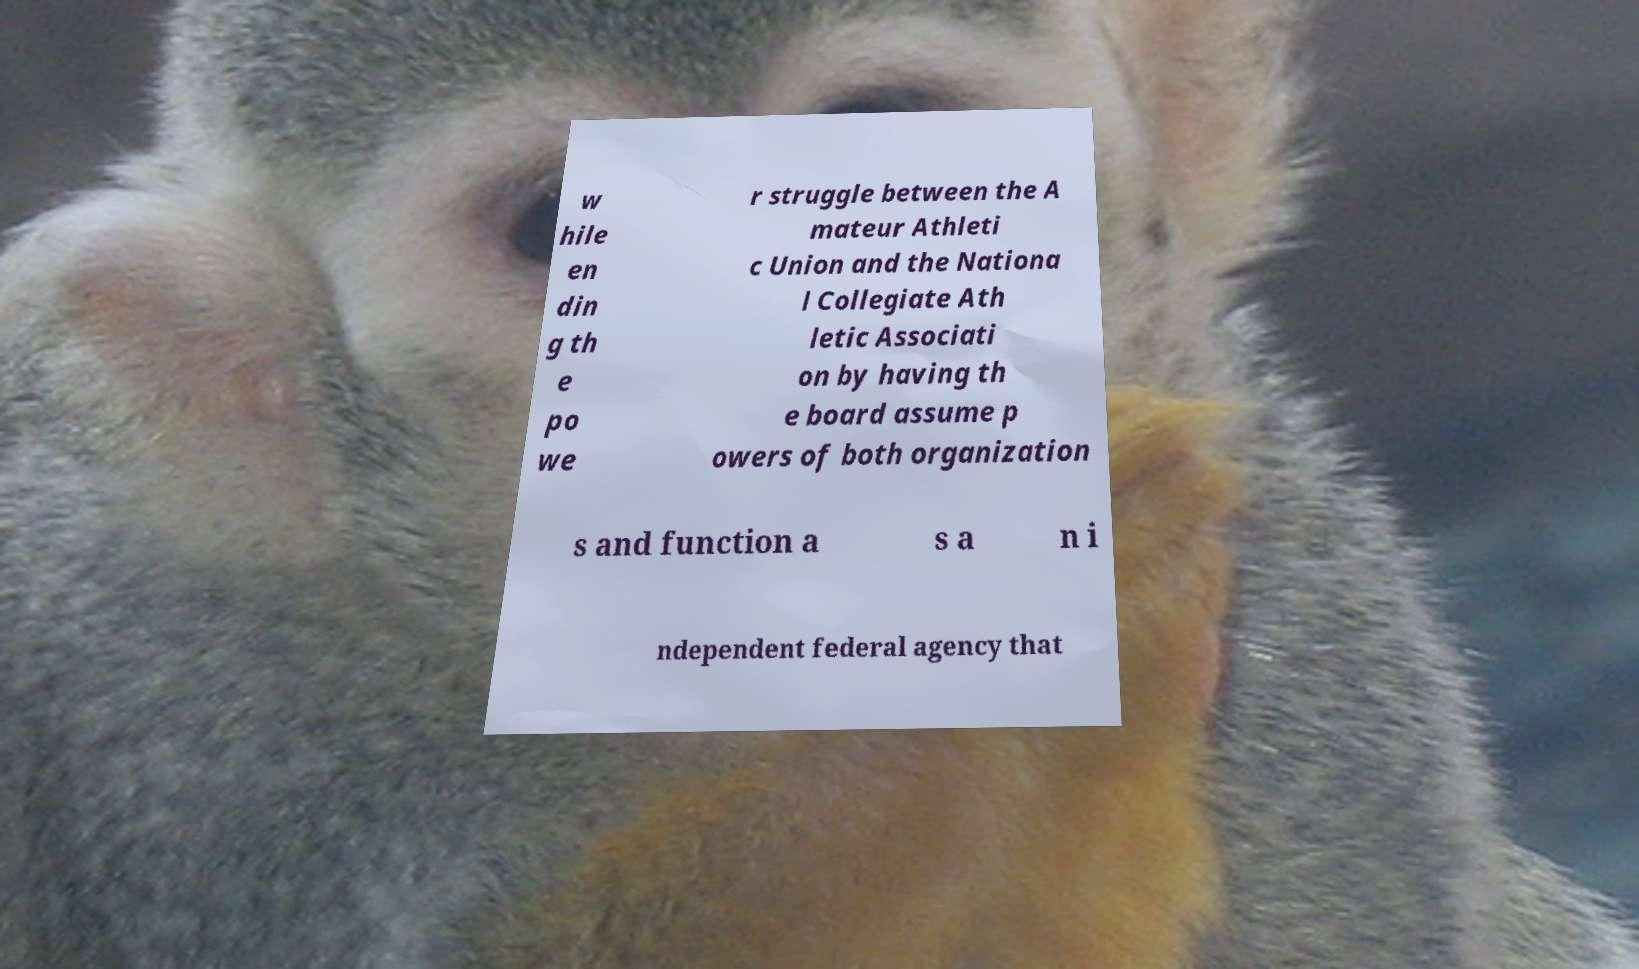Could you assist in decoding the text presented in this image and type it out clearly? w hile en din g th e po we r struggle between the A mateur Athleti c Union and the Nationa l Collegiate Ath letic Associati on by having th e board assume p owers of both organization s and function a s a n i ndependent federal agency that 